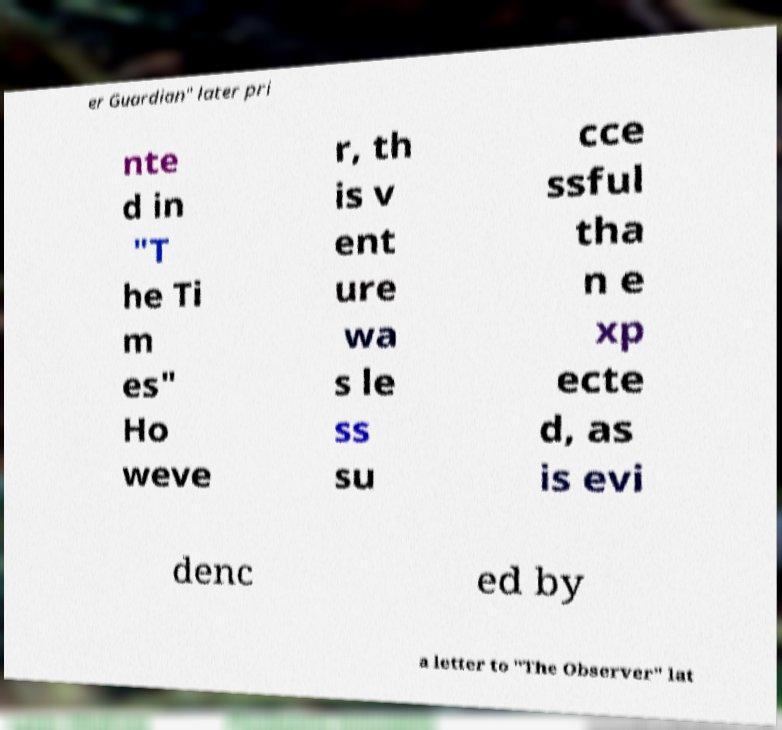Please identify and transcribe the text found in this image. er Guardian" later pri nte d in "T he Ti m es" Ho weve r, th is v ent ure wa s le ss su cce ssful tha n e xp ecte d, as is evi denc ed by a letter to "The Observer" lat 